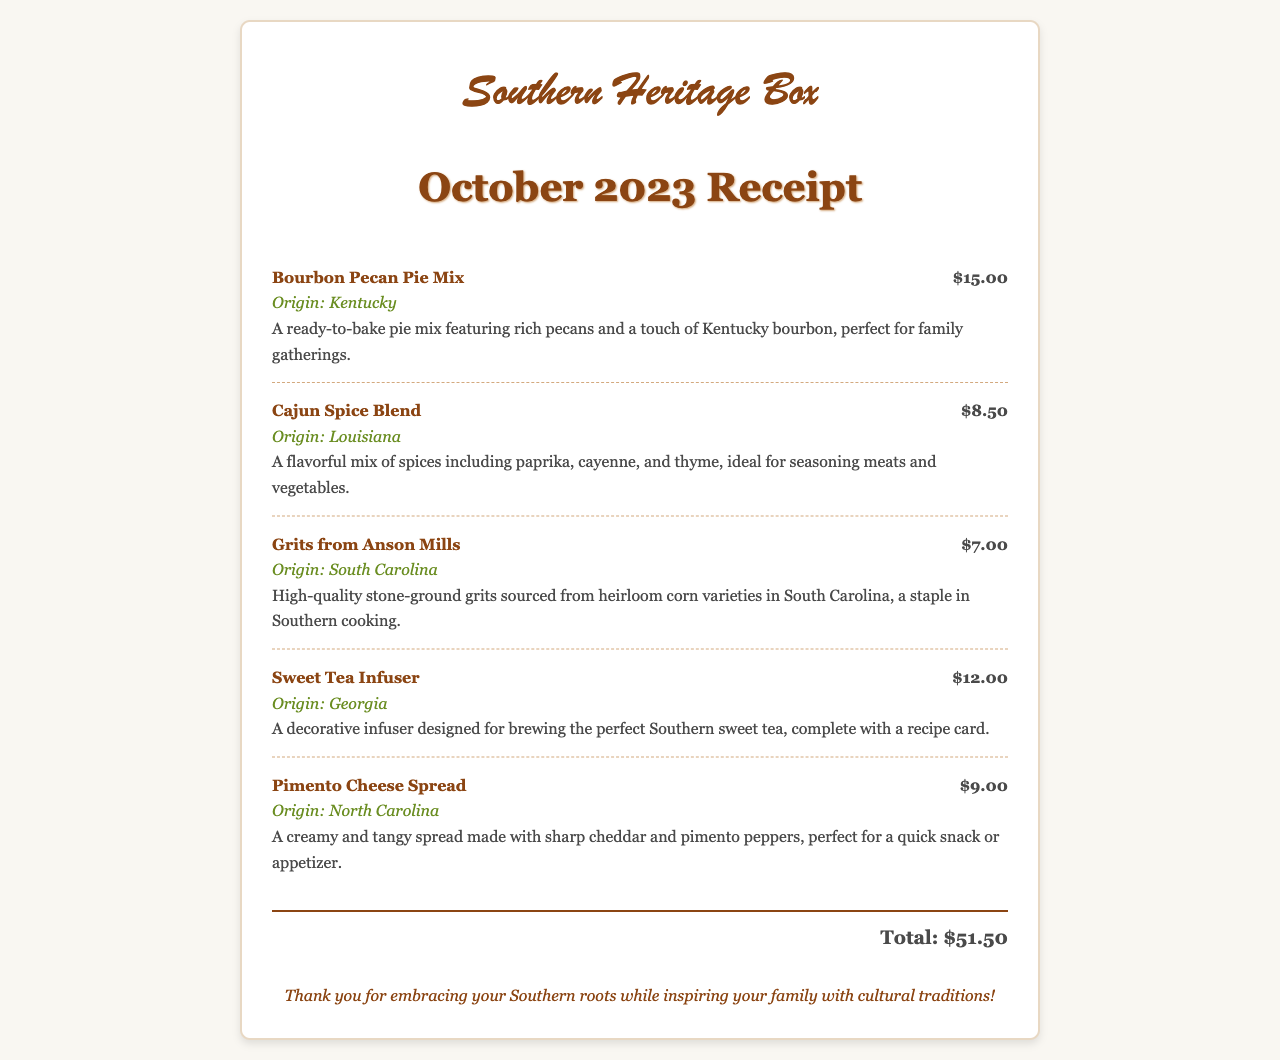What is the name of the subscription box? The subscription box is named "Southern Heritage Box" as indicated at the top of the receipt.
Answer: Southern Heritage Box What items are included in the box? The receipt lists several items including Bourbon Pecan Pie Mix, Cajun Spice Blend, Grits from Anson Mills, Sweet Tea Infuser, and Pimento Cheese Spread.
Answer: Bourbon Pecan Pie Mix, Cajun Spice Blend, Grits from Anson Mills, Sweet Tea Infuser, Pimento Cheese Spread How much does the Sweet Tea Infuser cost? The cost of the Sweet Tea Infuser is mentioned as $12.00 in the receipt.
Answer: $12.00 What is the origin of the Cajun Spice Blend? The origin of the Cajun Spice Blend is indicated as Louisiana in the document.
Answer: Louisiana What is the total amount for the subscription box? The total amount listed at the bottom of the receipt sums all the item prices, which is $51.50.
Answer: $51.50 Which item is made with sharp cheddar and pimento peppers? The item made with sharp cheddar and pimento peppers is specifically identified as Pimento Cheese Spread on the receipt.
Answer: Pimento Cheese Spread How many items are listed in the receipt? The receipt lists five items included in the subscription box.
Answer: Five What flavor does the Bourbon Pecan Pie Mix include? The Bourbon Pecan Pie Mix includes a touch of Kentucky bourbon as stated in the description.
Answer: Kentucky bourbon What does the thank you message express? The thank you message expresses gratitude for embracing Southern roots and inspiring family traditions.
Answer: Embracing Southern roots and inspiring family traditions 